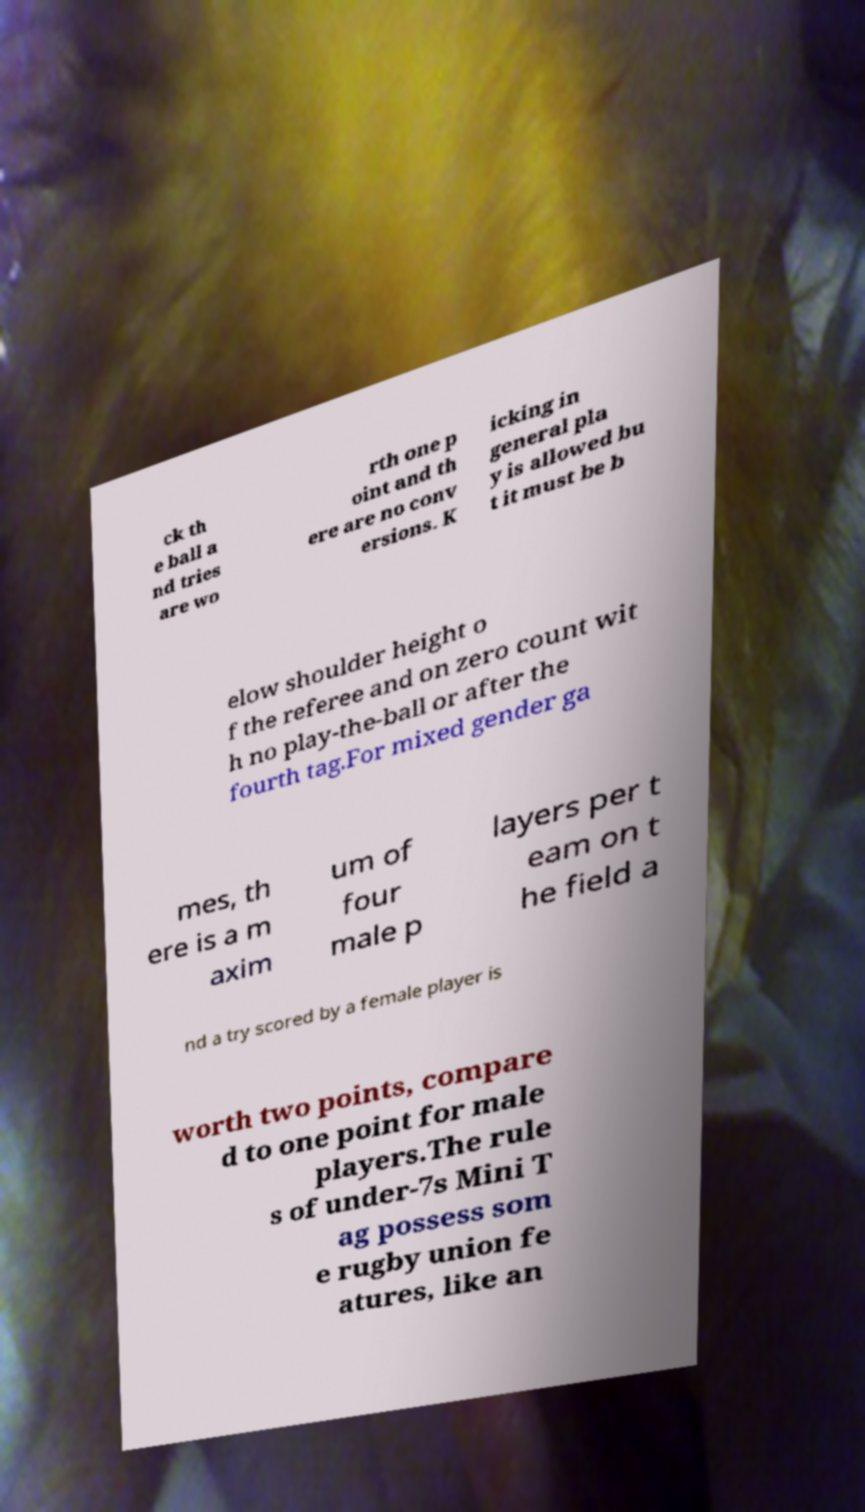Could you extract and type out the text from this image? ck th e ball a nd tries are wo rth one p oint and th ere are no conv ersions. K icking in general pla y is allowed bu t it must be b elow shoulder height o f the referee and on zero count wit h no play-the-ball or after the fourth tag.For mixed gender ga mes, th ere is a m axim um of four male p layers per t eam on t he field a nd a try scored by a female player is worth two points, compare d to one point for male players.The rule s of under-7s Mini T ag possess som e rugby union fe atures, like an 